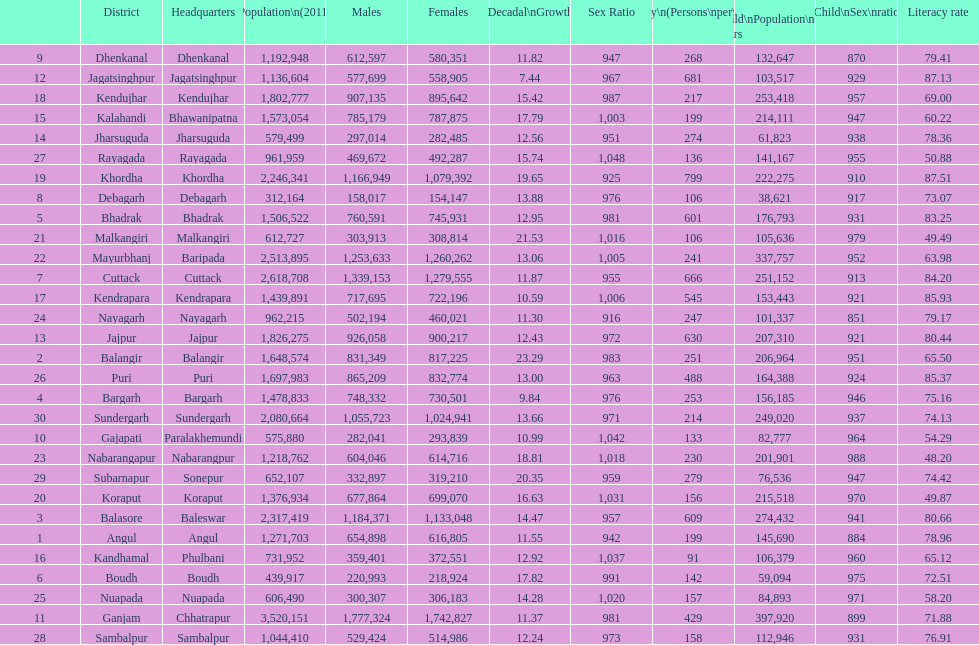Which district had the most people per km? Khordha. 